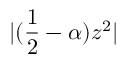<formula> <loc_0><loc_0><loc_500><loc_500>| ( \frac { 1 } { 2 } - \alpha ) z ^ { 2 } |</formula> 